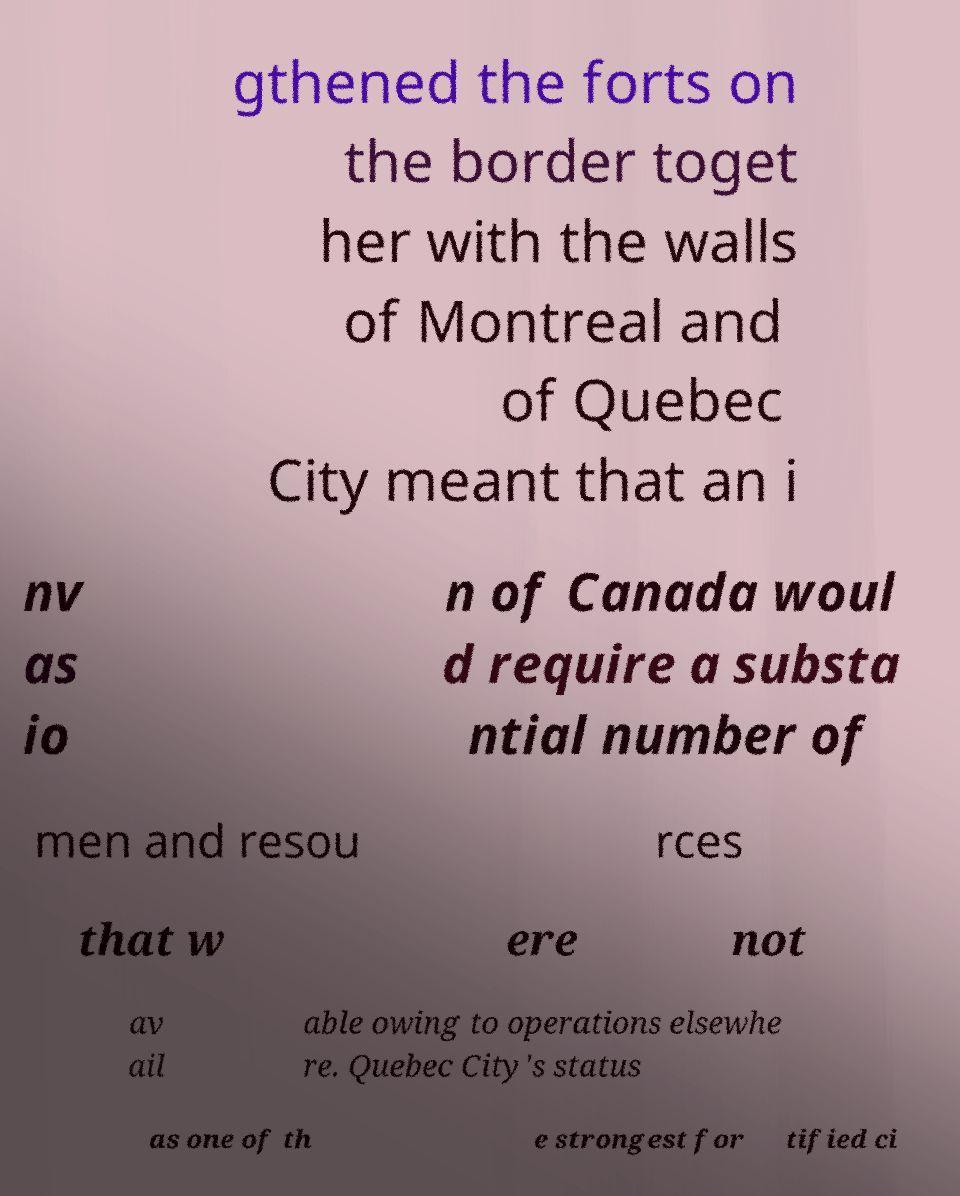I need the written content from this picture converted into text. Can you do that? gthened the forts on the border toget her with the walls of Montreal and of Quebec City meant that an i nv as io n of Canada woul d require a substa ntial number of men and resou rces that w ere not av ail able owing to operations elsewhe re. Quebec City's status as one of th e strongest for tified ci 